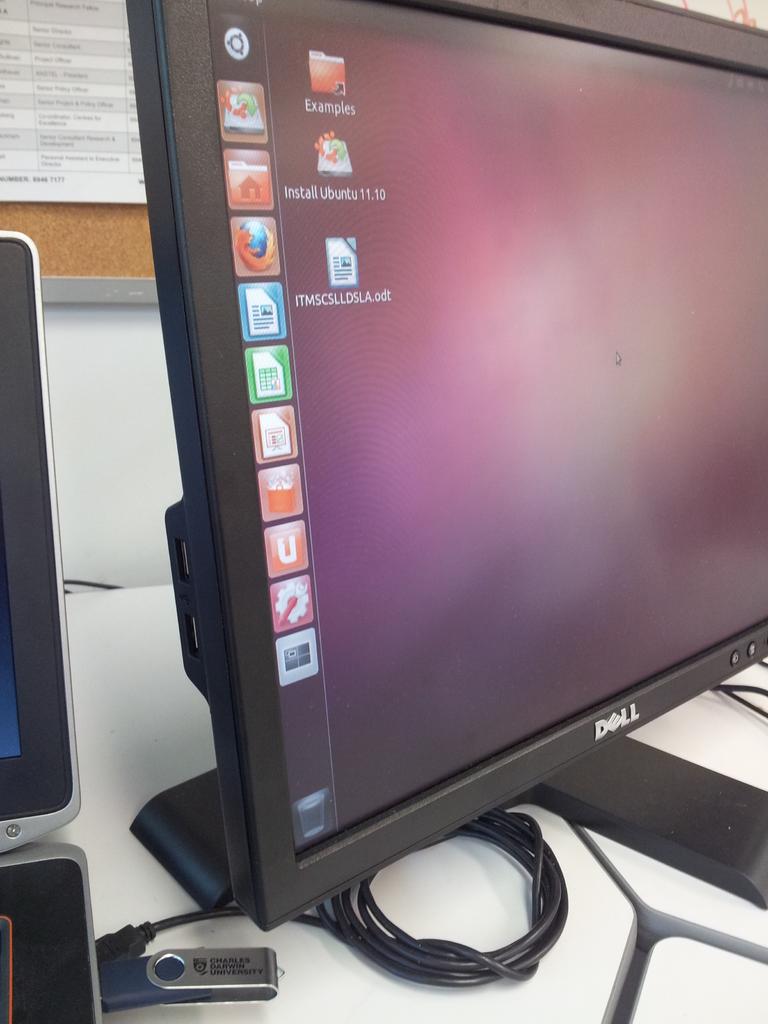What type of computer is this?
Your response must be concise. Dell. Who built the monitor?
Give a very brief answer. Dell. 